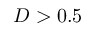Convert formula to latex. <formula><loc_0><loc_0><loc_500><loc_500>D > 0 . 5</formula> 